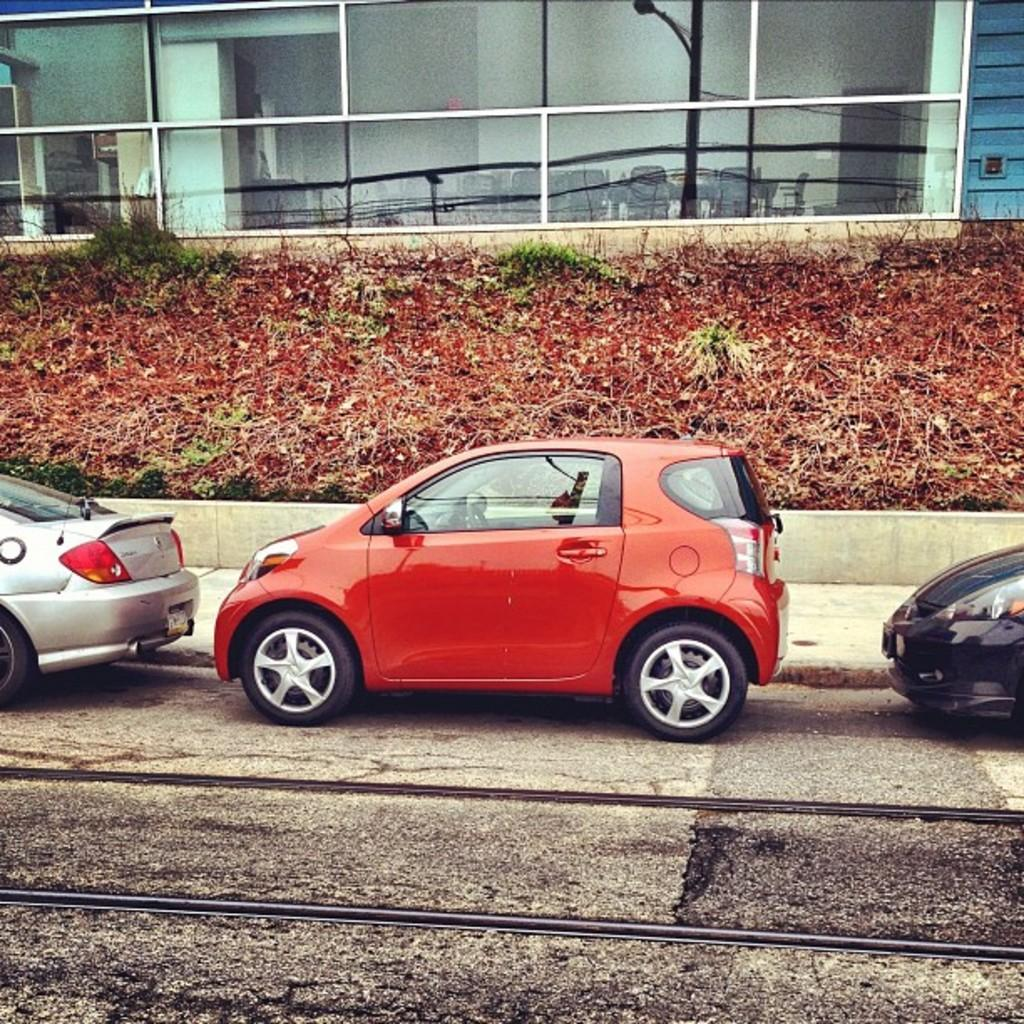What can be seen on the road in the image? There are vehicles on the road in the image. What type of vegetation is visible in the image? There is grass visible in the image. What kind of building can be seen in the image? There is a glass building in the image. What word is written on the grass in the image? There are no words written on the grass in the image. What action are the vehicles performing in the image? The vehicles are simply visible on the road in the image, and no specific action can be determined from the provided facts. 